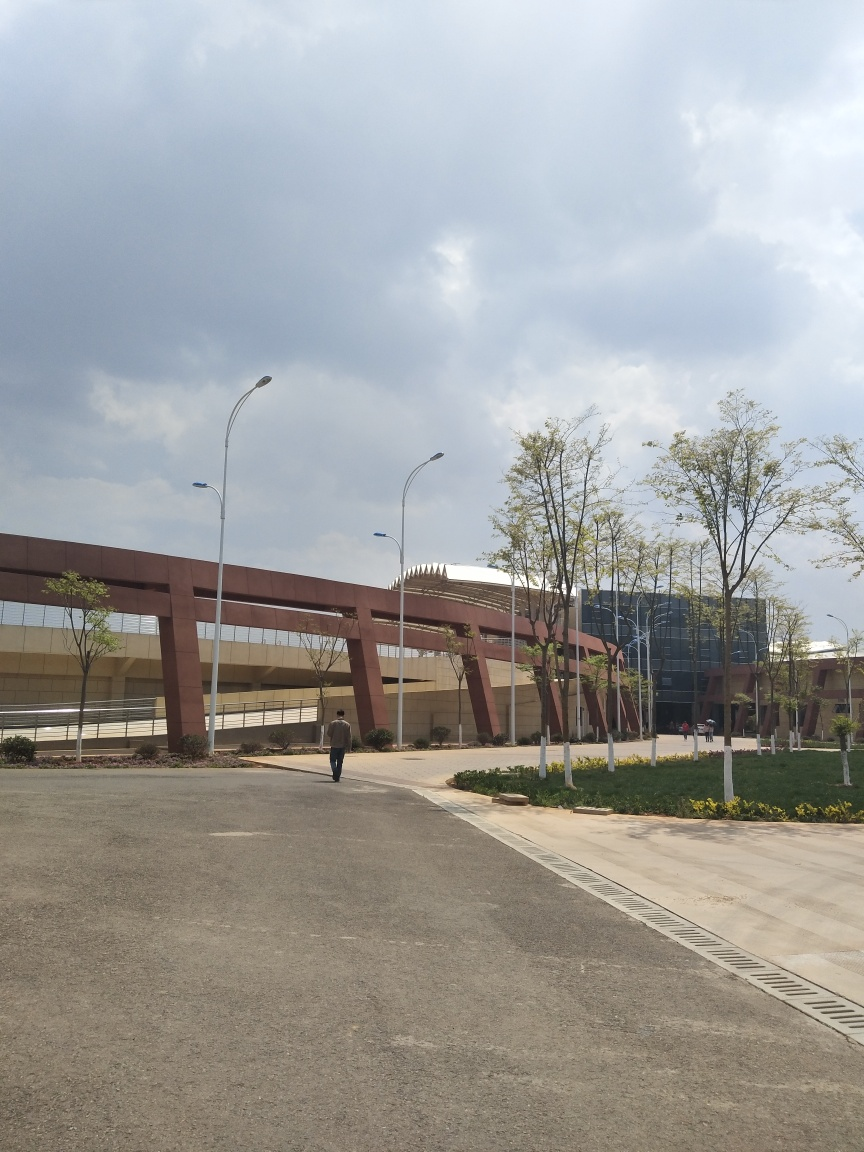What is the architectural style of the building in the background? The building showcases contemporary architectural elements, with its use of geometric shapes, glass facades, and linear designs that create a modern and sleek appearance. 